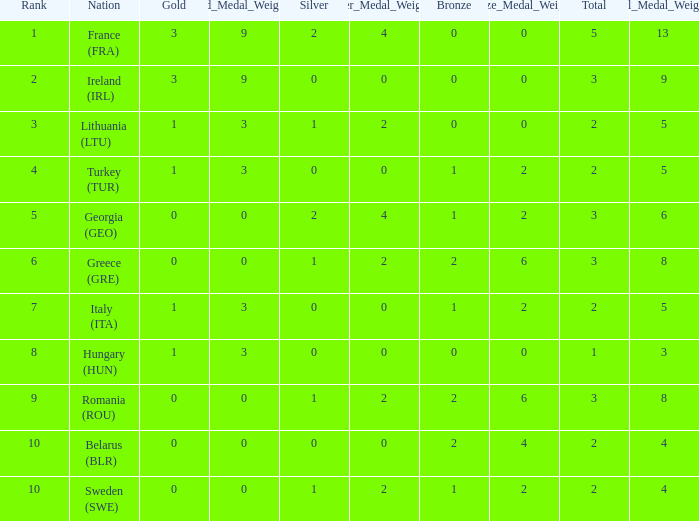What's the total of rank 8 when Silver medals are 0 and gold is more than 1? 0.0. 